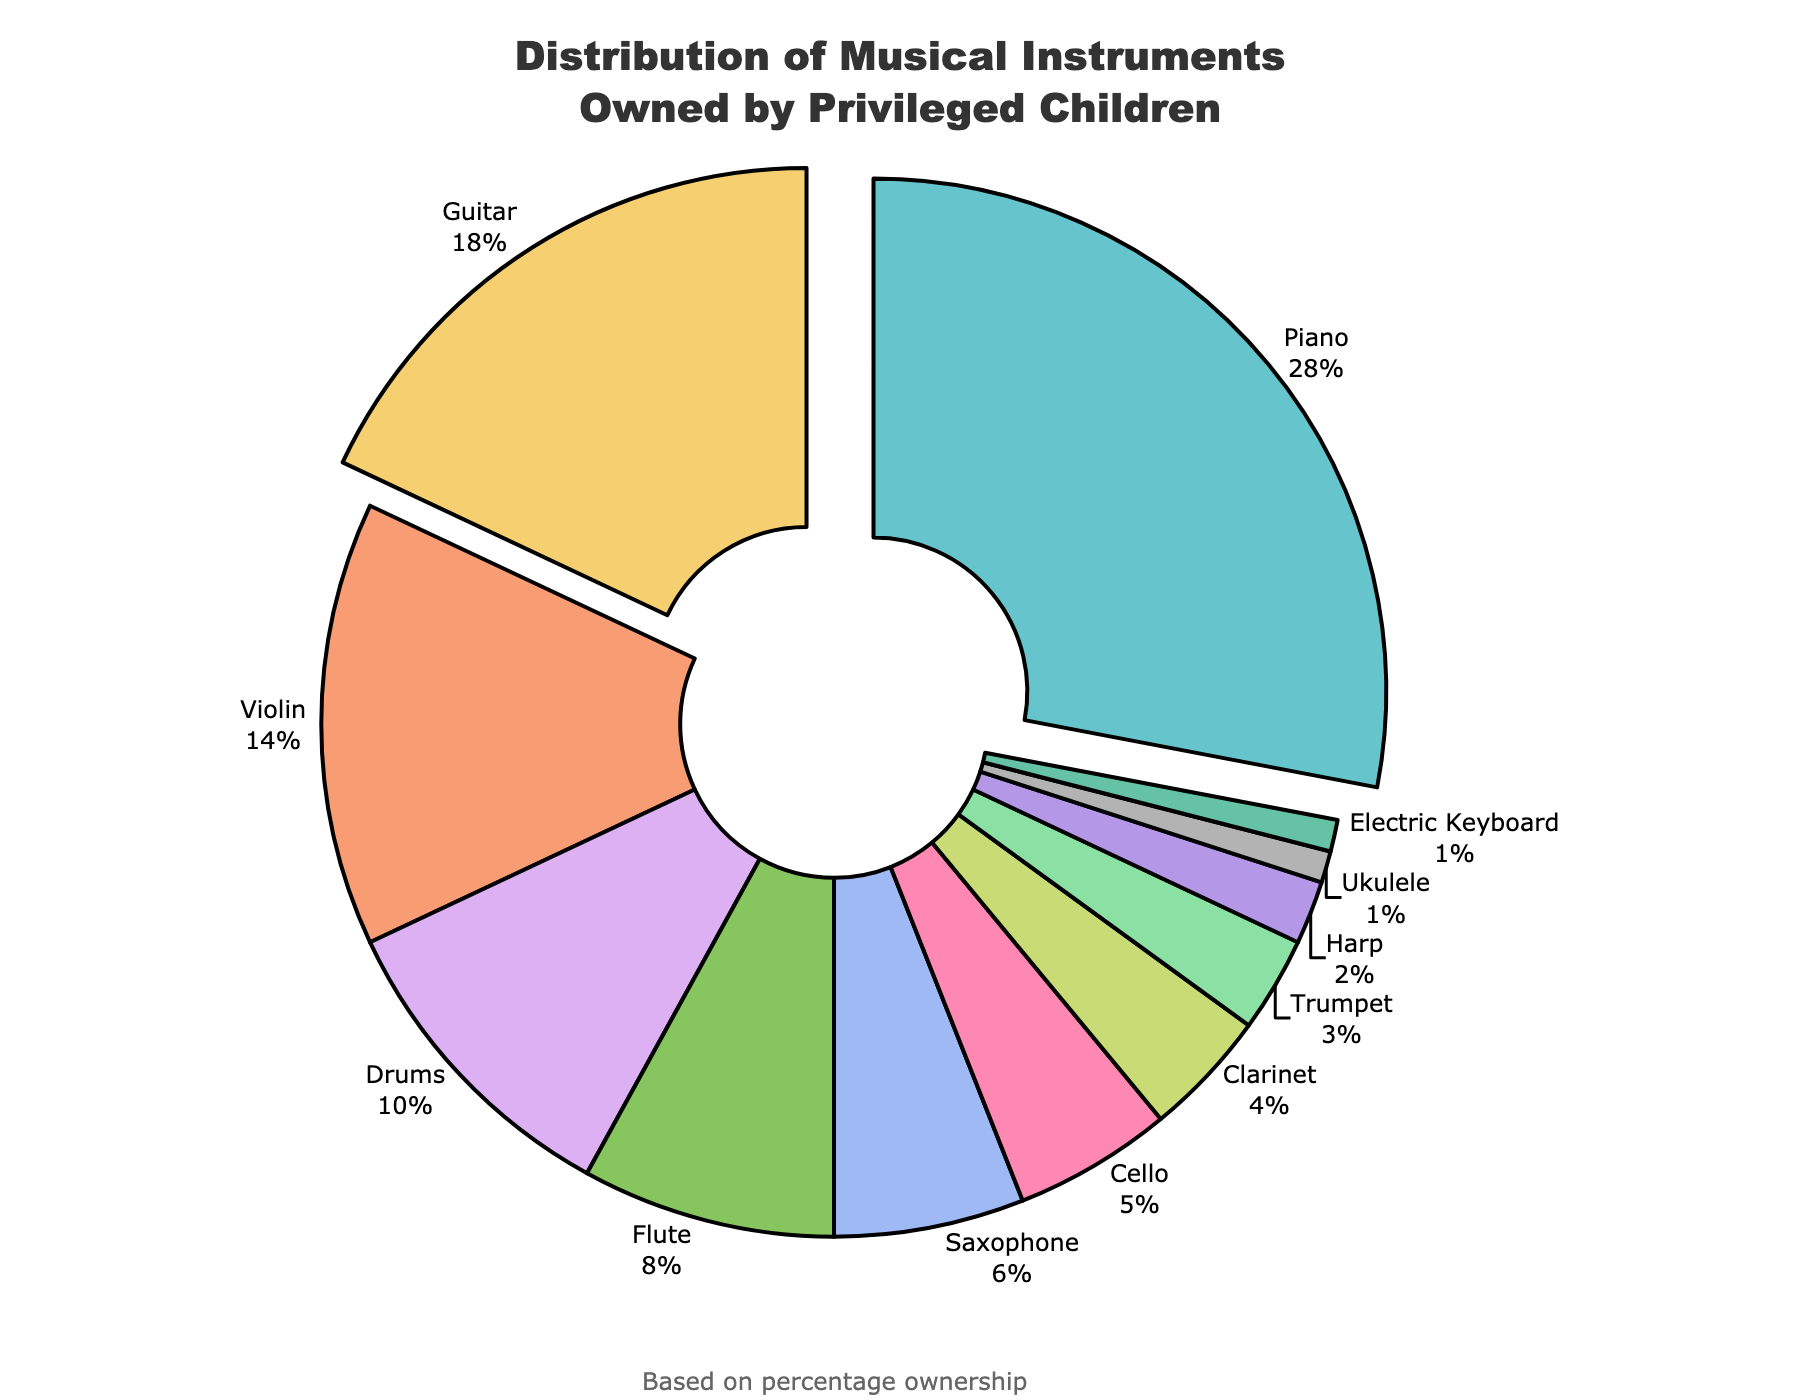What is the most commonly owned musical instrument among privileged children according to the pie chart? To find the most commonly owned instrument, look for the largest segment in the pie chart. The piano segment stands out as the largest.
Answer: Piano Which two instruments have the highest combined ownership percentage? Sum the two highest percentages: Piano (28%) and Guitar (18%). Their combined percentage is 28% + 18% = 46%.
Answer: Piano and Guitar By what percentage does the piano ownership exceed the drum ownership? Subtract the percentage of drums from the percentage of pianos: 28% (Piano) - 10% (Drums) = 18%.
Answer: 18% What is the total percentage of ownership for string instruments (Piano, Violin, Cello)? Sum the percentages of all string instruments: 28% (Piano) + 14% (Violin) + 5% (Cello) = 47%.
Answer: 47% Which instrument is owned by the smallest percentage of privileged children? Identify the smallest segment in the pie chart. The segments representing Ukulele and Electric Keyboard both have the smallest percentages.
Answer: Ukulele and Electric Keyboard Is the total ownership percent for woodwind instruments (Flute, Saxophone, Clarinet) greater than that for percussion instruments (Drums)? Sum the percentages for woodwind instruments: 8% (Flute) + 6% (Saxophone) + 4% (Clarinet) = 18%. Compare it to the percentage for Drums, which is 10%.
Answer: Yes What instrument is represented in light blue? Identify the instrument associated with the light blue color in the pie chart's color palette.
Answer: Cello Which is more commonly owned: a trumpet or a saxophone? Compare the percentages for Trumpet (3%) and Saxophone (6%). The Saxophone percentage is higher.
Answer: Saxophone How much less is the percentage ownership of the harp compared to the flute? Subtract the percentage of harp ownership from that of the flute: 8% (Flute) - 2% (Harp) = 6%.
Answer: 6% What is the difference in ownership between the clarinet and the saxophone? Subtract the clarinet percentage from the saxophone percentage: 6% (Saxophone) - 4% (Clarinet) = 2%.
Answer: 2% 